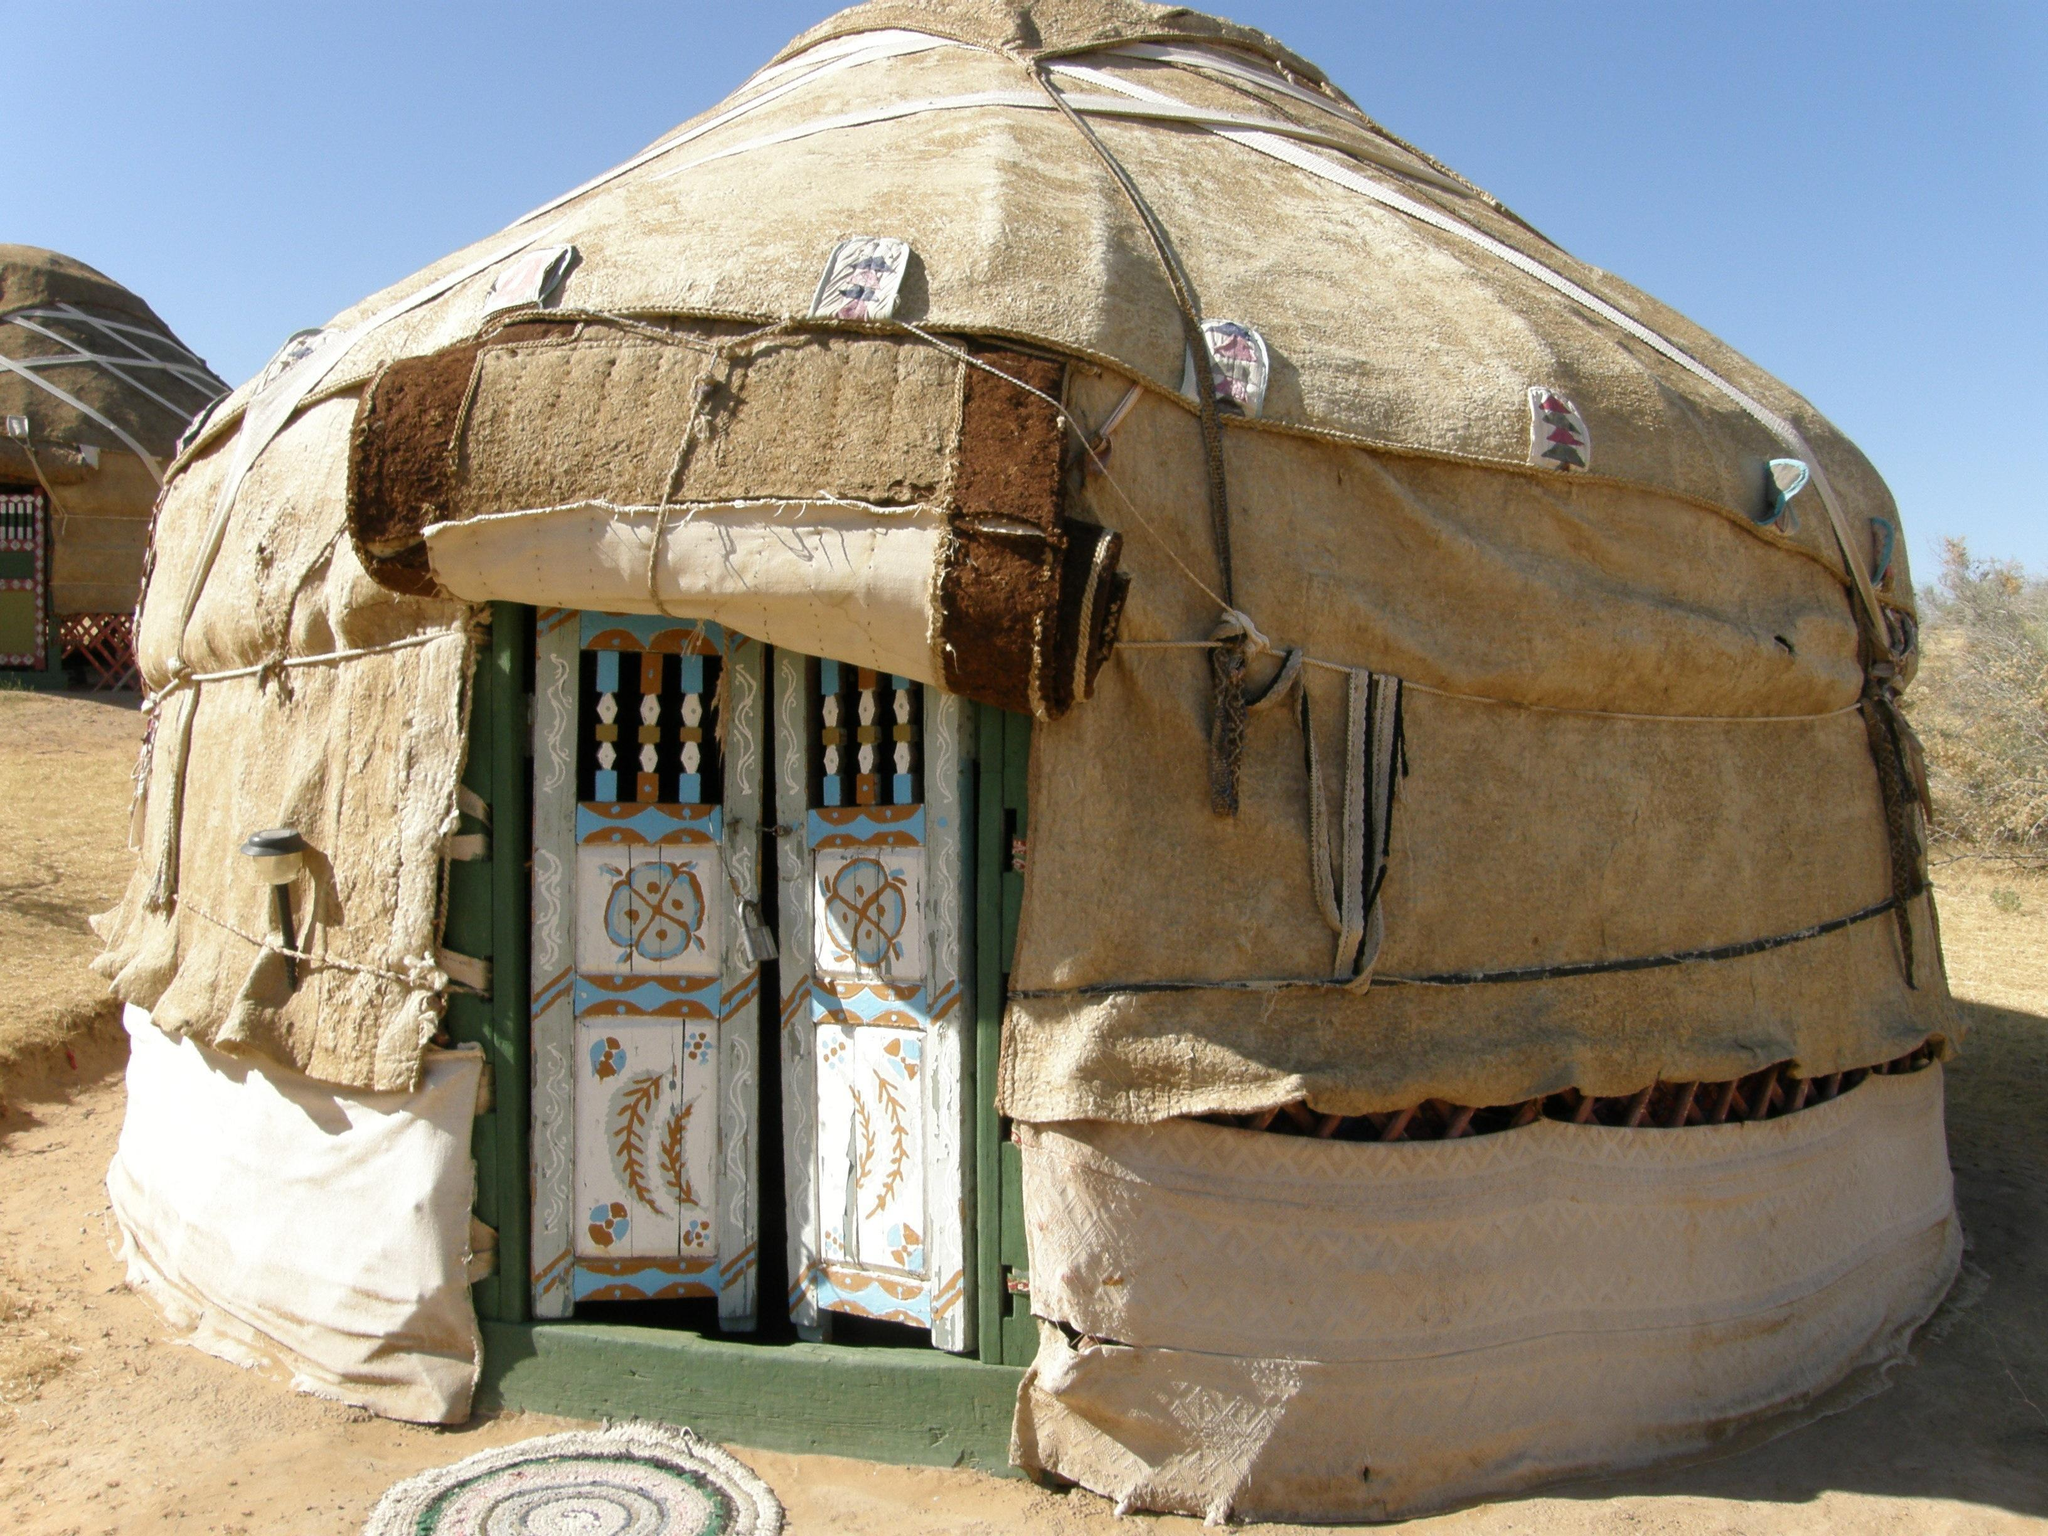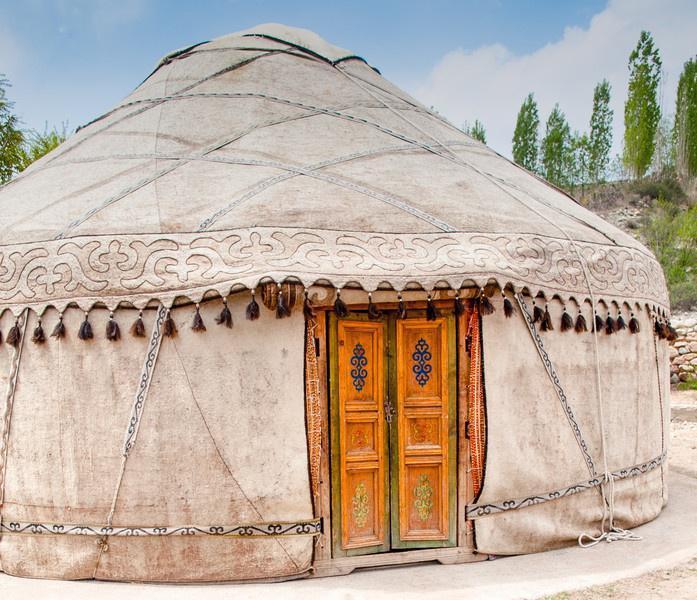The first image is the image on the left, the second image is the image on the right. For the images displayed, is the sentence "A single white yurt is photographed with its door facing directly toward the camera, and at least one person stands outside the doorway." factually correct? Answer yes or no. No. The first image is the image on the left, the second image is the image on the right. For the images shown, is this caption "At least one person is standing outside the hut in the image on the left." true? Answer yes or no. No. 